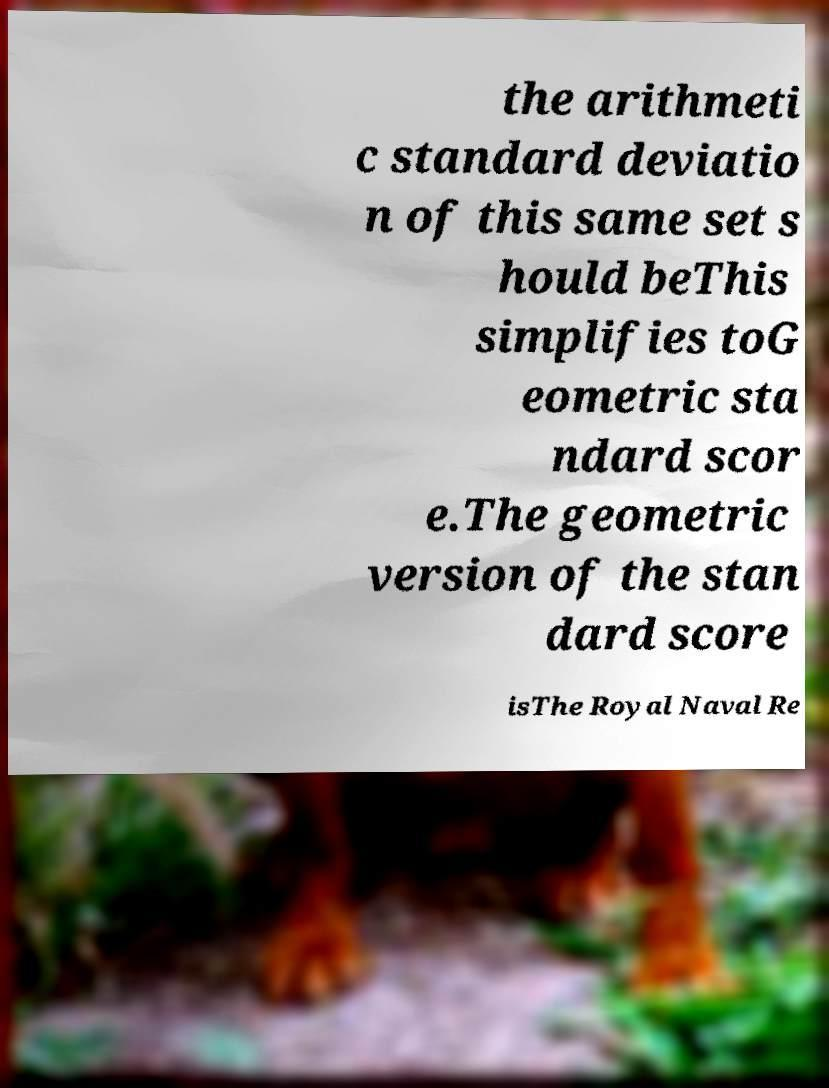Can you accurately transcribe the text from the provided image for me? the arithmeti c standard deviatio n of this same set s hould beThis simplifies toG eometric sta ndard scor e.The geometric version of the stan dard score isThe Royal Naval Re 